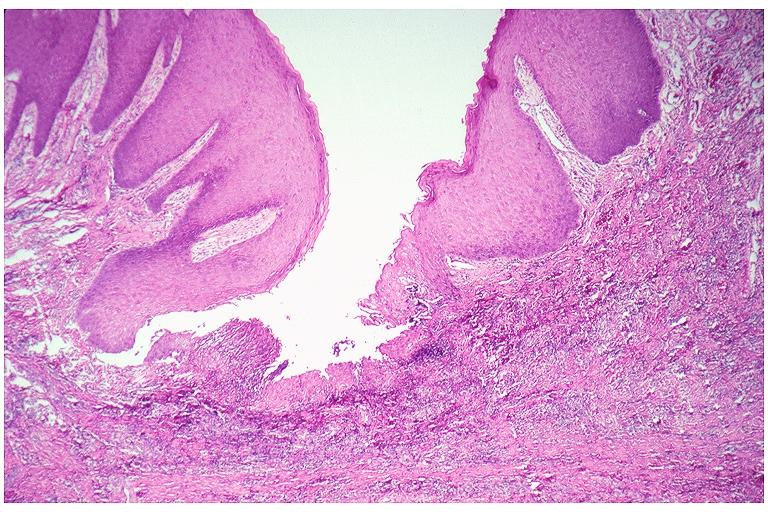s papillary astrocytoma present?
Answer the question using a single word or phrase. No 